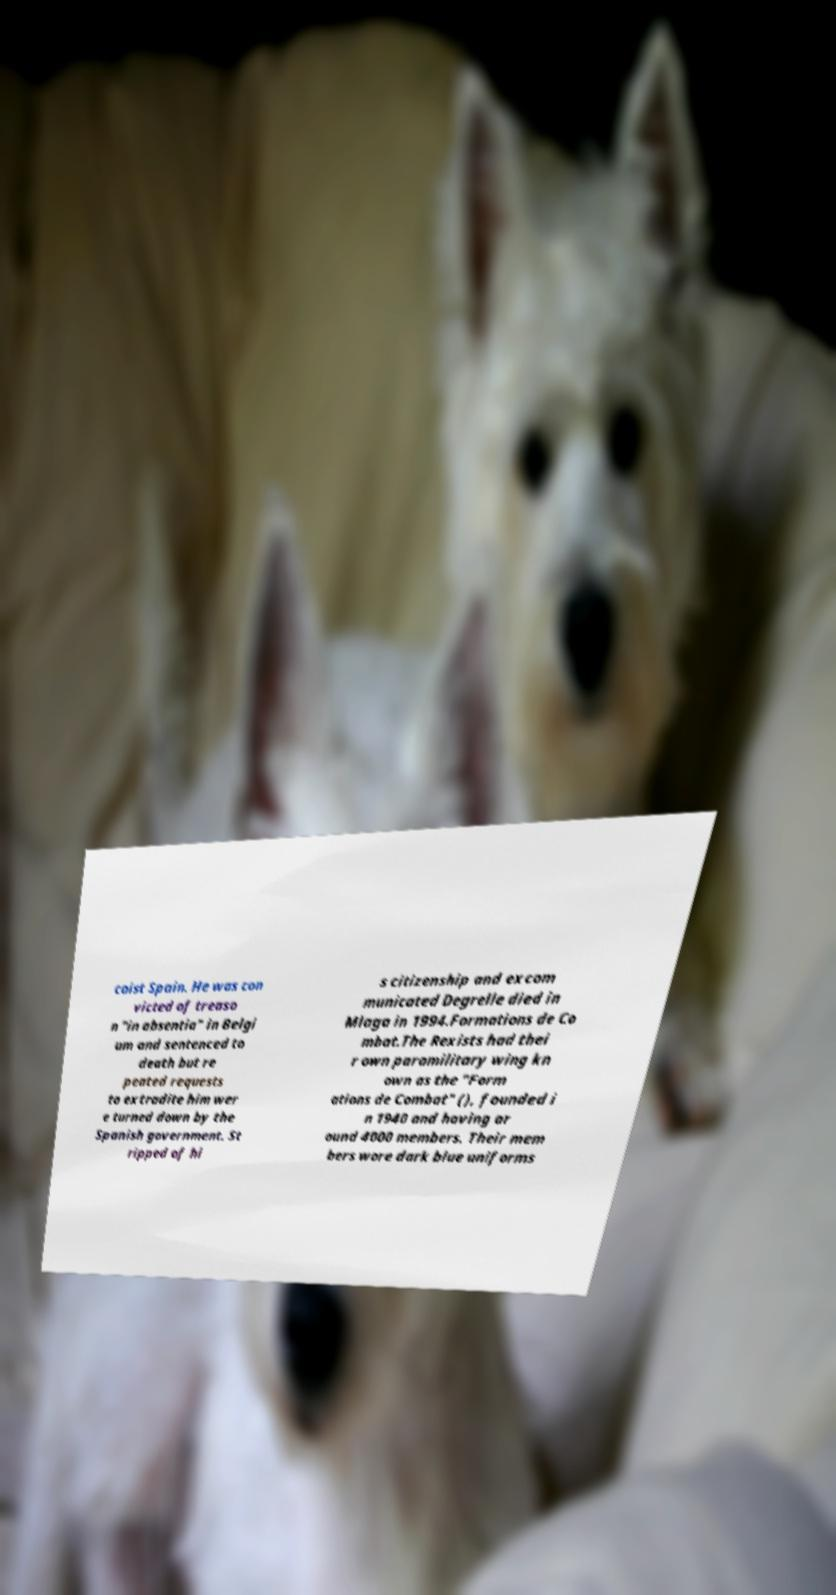Can you read and provide the text displayed in the image?This photo seems to have some interesting text. Can you extract and type it out for me? coist Spain. He was con victed of treaso n "in absentia" in Belgi um and sentenced to death but re peated requests to extradite him wer e turned down by the Spanish government. St ripped of hi s citizenship and excom municated Degrelle died in Mlaga in 1994.Formations de Co mbat.The Rexists had thei r own paramilitary wing kn own as the "Form ations de Combat" (), founded i n 1940 and having ar ound 4000 members. Their mem bers wore dark blue uniforms 